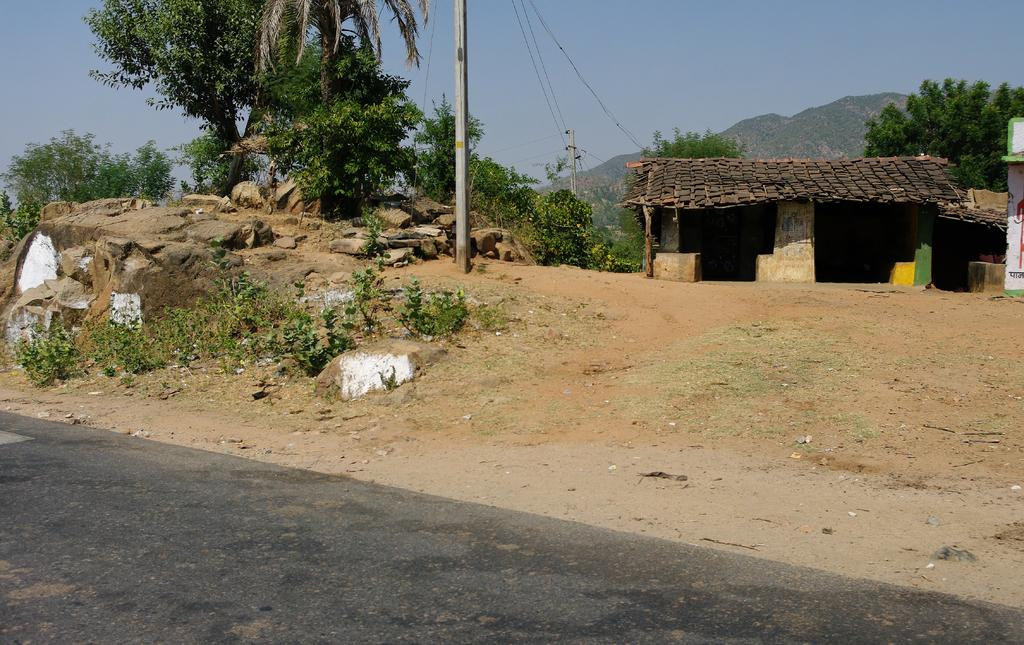What type of structure can be seen in the image? There is a house in the image. Are there any other houses nearby? Yes, there is another house beside the first house. What else can be seen in the image? There is a pole, a tree, stones, the sky, a tree at the back side of the house, a hill, and a cable wire visible in the image. How does the zipper on the house function in the image? There is no zipper present on the house in the image. What is the elbow of the hill doing in the image? There is no mention of an elbow in the image; hills do not have elbows. 